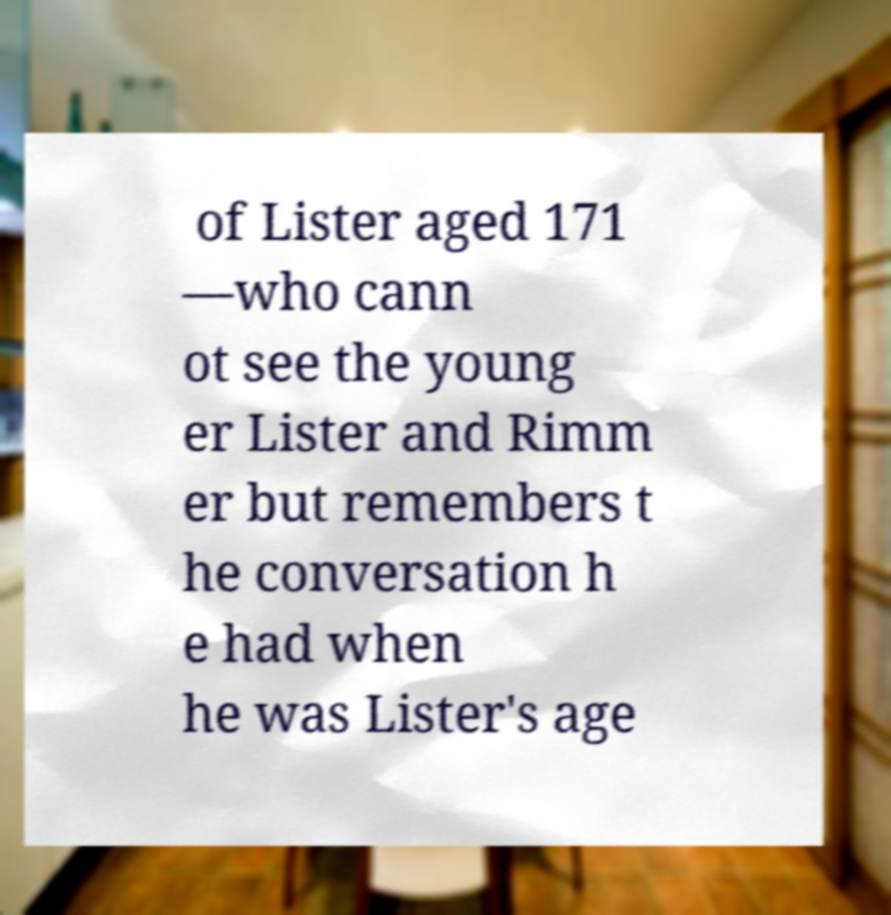For documentation purposes, I need the text within this image transcribed. Could you provide that? of Lister aged 171 —who cann ot see the young er Lister and Rimm er but remembers t he conversation h e had when he was Lister's age 